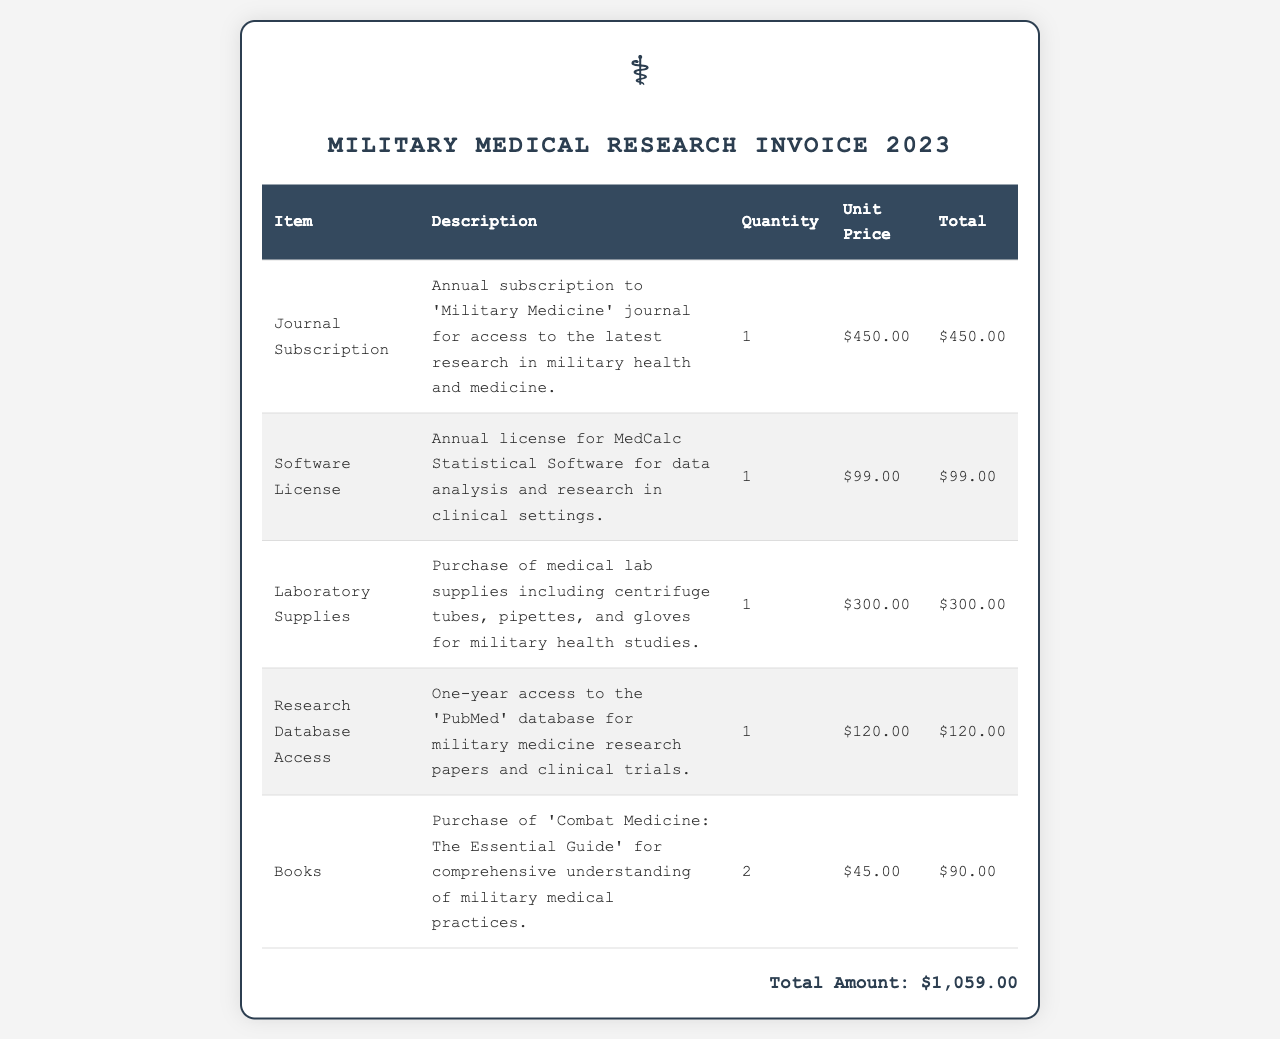what is the total amount on the invoice? The total amount is clearly stated at the bottom of the invoice as the sum of all items listed.
Answer: $1,059.00 how many journals were subscribed to? There is an entry for 'Journal Subscription' which indicates that one annual subscription was purchased.
Answer: 1 what is included in the laboratory supplies? The description of 'Laboratory Supplies' lists the purchase of various medical lab supplies.
Answer: Centrifuge tubes, pipettes, and gloves what is the unit price of the Software License? Each item in the invoice includes a unit price, and for the Software License, this was explicitly mentioned.
Answer: $99.00 how many books were purchased? The invoice indicates a purchase of two books, as mentioned in the entry for 'Books'.
Answer: 2 what is the name of the statistical software licensed? The specific software licensed for data analysis is named in the description of the respective entry.
Answer: MedCalc Statistical Software what is the description of the Research Database Access? The invoice provides a detailed description of the Research Database Access item.
Answer: One-year access to the 'PubMed' database how much did the laboratory supplies cost? The total for the laboratory supplies is specified in the invoice under the respective entry.
Answer: $300.00 